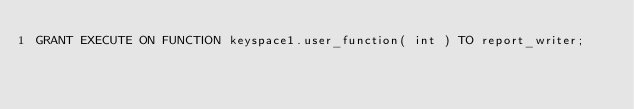Convert code to text. <code><loc_0><loc_0><loc_500><loc_500><_SQL_>GRANT EXECUTE ON FUNCTION keyspace1.user_function( int ) TO report_writer;
</code> 